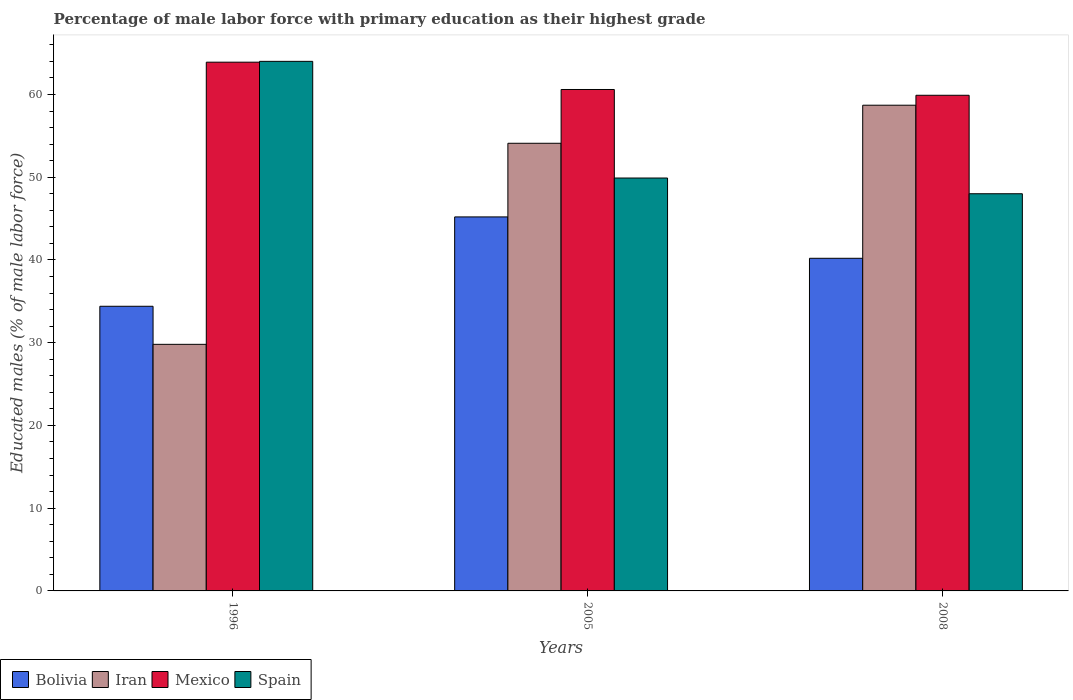How many groups of bars are there?
Your response must be concise. 3. Are the number of bars on each tick of the X-axis equal?
Offer a terse response. Yes. How many bars are there on the 1st tick from the left?
Your response must be concise. 4. What is the label of the 2nd group of bars from the left?
Your response must be concise. 2005. In how many cases, is the number of bars for a given year not equal to the number of legend labels?
Give a very brief answer. 0. What is the percentage of male labor force with primary education in Spain in 2008?
Your answer should be compact. 48. Across all years, what is the maximum percentage of male labor force with primary education in Bolivia?
Offer a very short reply. 45.2. What is the total percentage of male labor force with primary education in Spain in the graph?
Provide a succinct answer. 161.9. What is the difference between the percentage of male labor force with primary education in Iran in 2008 and the percentage of male labor force with primary education in Spain in 2005?
Offer a very short reply. 8.8. What is the average percentage of male labor force with primary education in Spain per year?
Make the answer very short. 53.97. In the year 1996, what is the difference between the percentage of male labor force with primary education in Bolivia and percentage of male labor force with primary education in Iran?
Give a very brief answer. 4.6. In how many years, is the percentage of male labor force with primary education in Bolivia greater than 20 %?
Your answer should be compact. 3. What is the ratio of the percentage of male labor force with primary education in Bolivia in 1996 to that in 2005?
Give a very brief answer. 0.76. Is the percentage of male labor force with primary education in Bolivia in 2005 less than that in 2008?
Provide a short and direct response. No. Is the difference between the percentage of male labor force with primary education in Bolivia in 1996 and 2005 greater than the difference between the percentage of male labor force with primary education in Iran in 1996 and 2005?
Your answer should be very brief. Yes. What is the difference between the highest and the second highest percentage of male labor force with primary education in Iran?
Give a very brief answer. 4.6. What is the difference between the highest and the lowest percentage of male labor force with primary education in Spain?
Your response must be concise. 16. In how many years, is the percentage of male labor force with primary education in Iran greater than the average percentage of male labor force with primary education in Iran taken over all years?
Provide a short and direct response. 2. Is the sum of the percentage of male labor force with primary education in Bolivia in 1996 and 2005 greater than the maximum percentage of male labor force with primary education in Iran across all years?
Your answer should be compact. Yes. What does the 3rd bar from the left in 1996 represents?
Your response must be concise. Mexico. What does the 1st bar from the right in 2005 represents?
Ensure brevity in your answer.  Spain. Is it the case that in every year, the sum of the percentage of male labor force with primary education in Bolivia and percentage of male labor force with primary education in Spain is greater than the percentage of male labor force with primary education in Mexico?
Your response must be concise. Yes. How many bars are there?
Ensure brevity in your answer.  12. Are all the bars in the graph horizontal?
Offer a very short reply. No. What is the difference between two consecutive major ticks on the Y-axis?
Provide a short and direct response. 10. Where does the legend appear in the graph?
Ensure brevity in your answer.  Bottom left. How are the legend labels stacked?
Your answer should be very brief. Horizontal. What is the title of the graph?
Your answer should be compact. Percentage of male labor force with primary education as their highest grade. Does "Argentina" appear as one of the legend labels in the graph?
Ensure brevity in your answer.  No. What is the label or title of the Y-axis?
Your answer should be compact. Educated males (% of male labor force). What is the Educated males (% of male labor force) of Bolivia in 1996?
Give a very brief answer. 34.4. What is the Educated males (% of male labor force) of Iran in 1996?
Your answer should be very brief. 29.8. What is the Educated males (% of male labor force) in Mexico in 1996?
Your answer should be very brief. 63.9. What is the Educated males (% of male labor force) in Spain in 1996?
Offer a terse response. 64. What is the Educated males (% of male labor force) in Bolivia in 2005?
Provide a succinct answer. 45.2. What is the Educated males (% of male labor force) in Iran in 2005?
Offer a terse response. 54.1. What is the Educated males (% of male labor force) of Mexico in 2005?
Your answer should be very brief. 60.6. What is the Educated males (% of male labor force) in Spain in 2005?
Ensure brevity in your answer.  49.9. What is the Educated males (% of male labor force) in Bolivia in 2008?
Your answer should be compact. 40.2. What is the Educated males (% of male labor force) in Iran in 2008?
Your response must be concise. 58.7. What is the Educated males (% of male labor force) of Mexico in 2008?
Provide a short and direct response. 59.9. Across all years, what is the maximum Educated males (% of male labor force) of Bolivia?
Your response must be concise. 45.2. Across all years, what is the maximum Educated males (% of male labor force) of Iran?
Keep it short and to the point. 58.7. Across all years, what is the maximum Educated males (% of male labor force) of Mexico?
Provide a succinct answer. 63.9. Across all years, what is the maximum Educated males (% of male labor force) of Spain?
Keep it short and to the point. 64. Across all years, what is the minimum Educated males (% of male labor force) of Bolivia?
Ensure brevity in your answer.  34.4. Across all years, what is the minimum Educated males (% of male labor force) in Iran?
Give a very brief answer. 29.8. Across all years, what is the minimum Educated males (% of male labor force) of Mexico?
Make the answer very short. 59.9. Across all years, what is the minimum Educated males (% of male labor force) of Spain?
Your answer should be very brief. 48. What is the total Educated males (% of male labor force) in Bolivia in the graph?
Offer a terse response. 119.8. What is the total Educated males (% of male labor force) in Iran in the graph?
Give a very brief answer. 142.6. What is the total Educated males (% of male labor force) in Mexico in the graph?
Offer a terse response. 184.4. What is the total Educated males (% of male labor force) of Spain in the graph?
Offer a terse response. 161.9. What is the difference between the Educated males (% of male labor force) in Bolivia in 1996 and that in 2005?
Your response must be concise. -10.8. What is the difference between the Educated males (% of male labor force) of Iran in 1996 and that in 2005?
Make the answer very short. -24.3. What is the difference between the Educated males (% of male labor force) of Spain in 1996 and that in 2005?
Your response must be concise. 14.1. What is the difference between the Educated males (% of male labor force) of Iran in 1996 and that in 2008?
Provide a succinct answer. -28.9. What is the difference between the Educated males (% of male labor force) of Spain in 1996 and that in 2008?
Offer a very short reply. 16. What is the difference between the Educated males (% of male labor force) in Bolivia in 2005 and that in 2008?
Ensure brevity in your answer.  5. What is the difference between the Educated males (% of male labor force) in Mexico in 2005 and that in 2008?
Your answer should be very brief. 0.7. What is the difference between the Educated males (% of male labor force) of Spain in 2005 and that in 2008?
Make the answer very short. 1.9. What is the difference between the Educated males (% of male labor force) of Bolivia in 1996 and the Educated males (% of male labor force) of Iran in 2005?
Keep it short and to the point. -19.7. What is the difference between the Educated males (% of male labor force) in Bolivia in 1996 and the Educated males (% of male labor force) in Mexico in 2005?
Your answer should be very brief. -26.2. What is the difference between the Educated males (% of male labor force) in Bolivia in 1996 and the Educated males (% of male labor force) in Spain in 2005?
Provide a succinct answer. -15.5. What is the difference between the Educated males (% of male labor force) in Iran in 1996 and the Educated males (% of male labor force) in Mexico in 2005?
Your response must be concise. -30.8. What is the difference between the Educated males (% of male labor force) of Iran in 1996 and the Educated males (% of male labor force) of Spain in 2005?
Make the answer very short. -20.1. What is the difference between the Educated males (% of male labor force) of Bolivia in 1996 and the Educated males (% of male labor force) of Iran in 2008?
Provide a short and direct response. -24.3. What is the difference between the Educated males (% of male labor force) of Bolivia in 1996 and the Educated males (% of male labor force) of Mexico in 2008?
Make the answer very short. -25.5. What is the difference between the Educated males (% of male labor force) of Bolivia in 1996 and the Educated males (% of male labor force) of Spain in 2008?
Your response must be concise. -13.6. What is the difference between the Educated males (% of male labor force) in Iran in 1996 and the Educated males (% of male labor force) in Mexico in 2008?
Give a very brief answer. -30.1. What is the difference between the Educated males (% of male labor force) in Iran in 1996 and the Educated males (% of male labor force) in Spain in 2008?
Provide a short and direct response. -18.2. What is the difference between the Educated males (% of male labor force) of Mexico in 1996 and the Educated males (% of male labor force) of Spain in 2008?
Your answer should be very brief. 15.9. What is the difference between the Educated males (% of male labor force) in Bolivia in 2005 and the Educated males (% of male labor force) in Iran in 2008?
Your answer should be very brief. -13.5. What is the difference between the Educated males (% of male labor force) in Bolivia in 2005 and the Educated males (% of male labor force) in Mexico in 2008?
Your answer should be very brief. -14.7. What is the difference between the Educated males (% of male labor force) of Iran in 2005 and the Educated males (% of male labor force) of Mexico in 2008?
Your answer should be very brief. -5.8. What is the average Educated males (% of male labor force) of Bolivia per year?
Keep it short and to the point. 39.93. What is the average Educated males (% of male labor force) in Iran per year?
Your answer should be very brief. 47.53. What is the average Educated males (% of male labor force) in Mexico per year?
Provide a short and direct response. 61.47. What is the average Educated males (% of male labor force) of Spain per year?
Give a very brief answer. 53.97. In the year 1996, what is the difference between the Educated males (% of male labor force) of Bolivia and Educated males (% of male labor force) of Iran?
Your response must be concise. 4.6. In the year 1996, what is the difference between the Educated males (% of male labor force) in Bolivia and Educated males (% of male labor force) in Mexico?
Offer a terse response. -29.5. In the year 1996, what is the difference between the Educated males (% of male labor force) of Bolivia and Educated males (% of male labor force) of Spain?
Make the answer very short. -29.6. In the year 1996, what is the difference between the Educated males (% of male labor force) of Iran and Educated males (% of male labor force) of Mexico?
Offer a terse response. -34.1. In the year 1996, what is the difference between the Educated males (% of male labor force) in Iran and Educated males (% of male labor force) in Spain?
Provide a succinct answer. -34.2. In the year 1996, what is the difference between the Educated males (% of male labor force) in Mexico and Educated males (% of male labor force) in Spain?
Your answer should be compact. -0.1. In the year 2005, what is the difference between the Educated males (% of male labor force) of Bolivia and Educated males (% of male labor force) of Iran?
Give a very brief answer. -8.9. In the year 2005, what is the difference between the Educated males (% of male labor force) in Bolivia and Educated males (% of male labor force) in Mexico?
Offer a very short reply. -15.4. In the year 2005, what is the difference between the Educated males (% of male labor force) in Bolivia and Educated males (% of male labor force) in Spain?
Provide a succinct answer. -4.7. In the year 2008, what is the difference between the Educated males (% of male labor force) in Bolivia and Educated males (% of male labor force) in Iran?
Your response must be concise. -18.5. In the year 2008, what is the difference between the Educated males (% of male labor force) in Bolivia and Educated males (% of male labor force) in Mexico?
Your answer should be compact. -19.7. In the year 2008, what is the difference between the Educated males (% of male labor force) in Iran and Educated males (% of male labor force) in Mexico?
Your answer should be very brief. -1.2. In the year 2008, what is the difference between the Educated males (% of male labor force) of Iran and Educated males (% of male labor force) of Spain?
Your response must be concise. 10.7. In the year 2008, what is the difference between the Educated males (% of male labor force) of Mexico and Educated males (% of male labor force) of Spain?
Offer a very short reply. 11.9. What is the ratio of the Educated males (% of male labor force) of Bolivia in 1996 to that in 2005?
Ensure brevity in your answer.  0.76. What is the ratio of the Educated males (% of male labor force) in Iran in 1996 to that in 2005?
Provide a short and direct response. 0.55. What is the ratio of the Educated males (% of male labor force) in Mexico in 1996 to that in 2005?
Give a very brief answer. 1.05. What is the ratio of the Educated males (% of male labor force) in Spain in 1996 to that in 2005?
Offer a terse response. 1.28. What is the ratio of the Educated males (% of male labor force) in Bolivia in 1996 to that in 2008?
Offer a very short reply. 0.86. What is the ratio of the Educated males (% of male labor force) of Iran in 1996 to that in 2008?
Keep it short and to the point. 0.51. What is the ratio of the Educated males (% of male labor force) in Mexico in 1996 to that in 2008?
Your answer should be compact. 1.07. What is the ratio of the Educated males (% of male labor force) of Bolivia in 2005 to that in 2008?
Give a very brief answer. 1.12. What is the ratio of the Educated males (% of male labor force) in Iran in 2005 to that in 2008?
Ensure brevity in your answer.  0.92. What is the ratio of the Educated males (% of male labor force) of Mexico in 2005 to that in 2008?
Ensure brevity in your answer.  1.01. What is the ratio of the Educated males (% of male labor force) in Spain in 2005 to that in 2008?
Provide a succinct answer. 1.04. What is the difference between the highest and the second highest Educated males (% of male labor force) in Iran?
Offer a terse response. 4.6. What is the difference between the highest and the second highest Educated males (% of male labor force) of Spain?
Make the answer very short. 14.1. What is the difference between the highest and the lowest Educated males (% of male labor force) of Bolivia?
Give a very brief answer. 10.8. What is the difference between the highest and the lowest Educated males (% of male labor force) in Iran?
Offer a very short reply. 28.9. What is the difference between the highest and the lowest Educated males (% of male labor force) in Spain?
Ensure brevity in your answer.  16. 